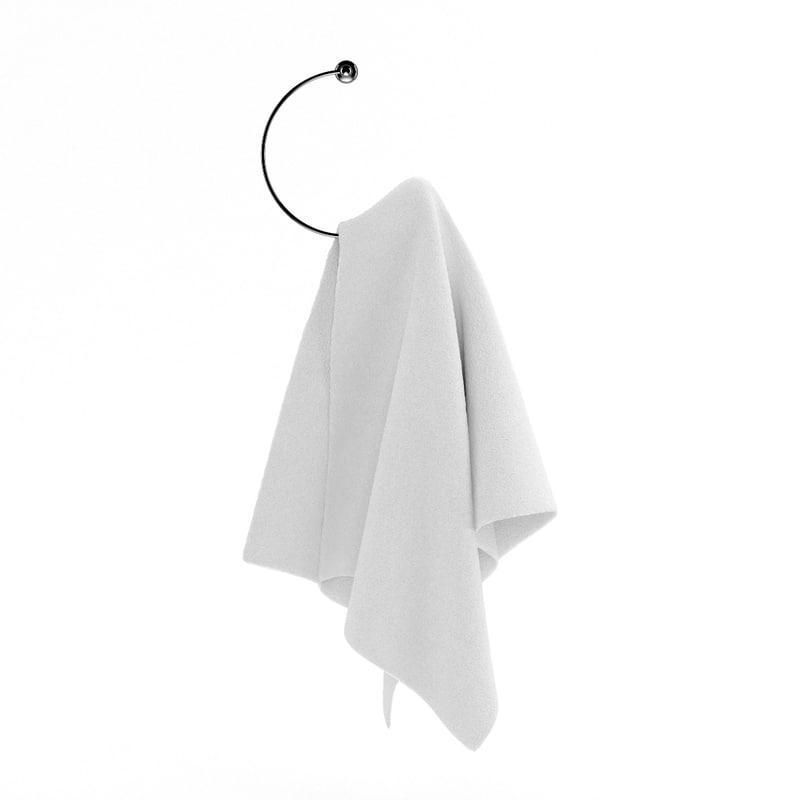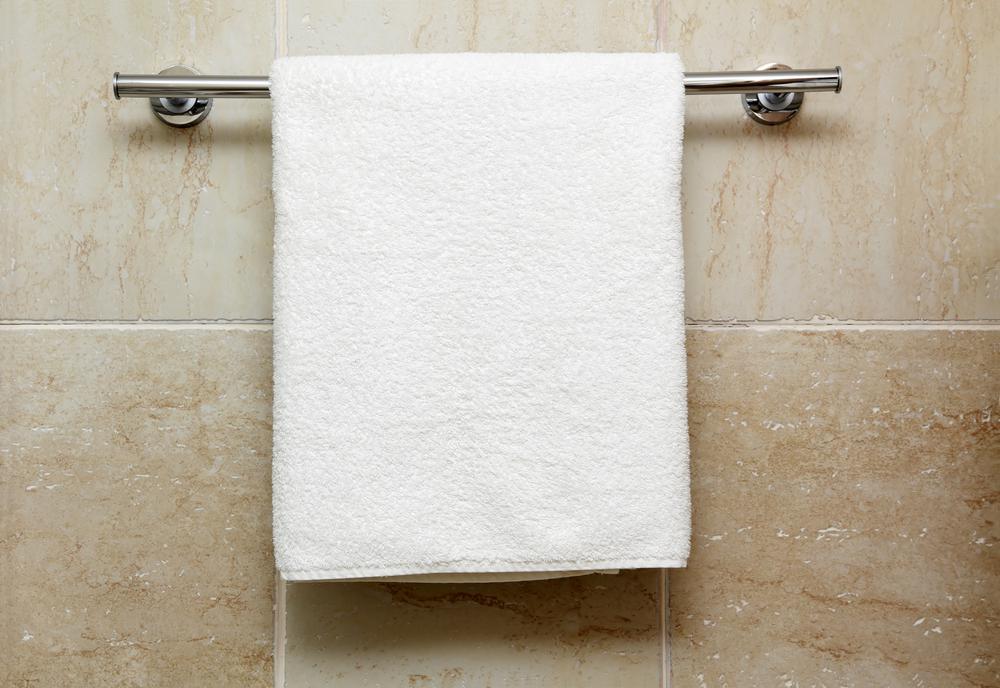The first image is the image on the left, the second image is the image on the right. Evaluate the accuracy of this statement regarding the images: "In one of the images there is a single white towel hanging on a towel bar.". Is it true? Answer yes or no. Yes. 